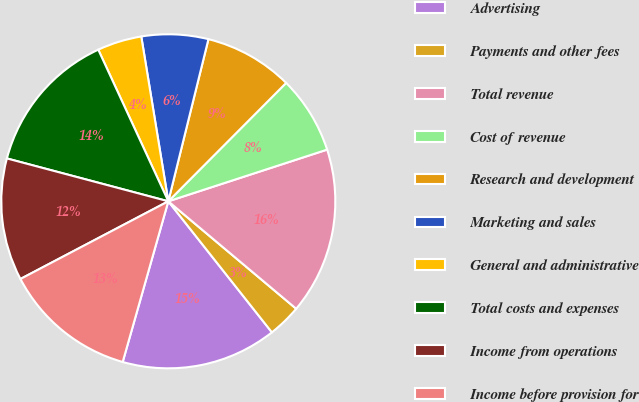<chart> <loc_0><loc_0><loc_500><loc_500><pie_chart><fcel>Advertising<fcel>Payments and other fees<fcel>Total revenue<fcel>Cost of revenue<fcel>Research and development<fcel>Marketing and sales<fcel>General and administrative<fcel>Total costs and expenses<fcel>Income from operations<fcel>Income before provision for<nl><fcel>15.05%<fcel>3.23%<fcel>16.13%<fcel>7.53%<fcel>8.6%<fcel>6.45%<fcel>4.3%<fcel>13.98%<fcel>11.83%<fcel>12.9%<nl></chart> 